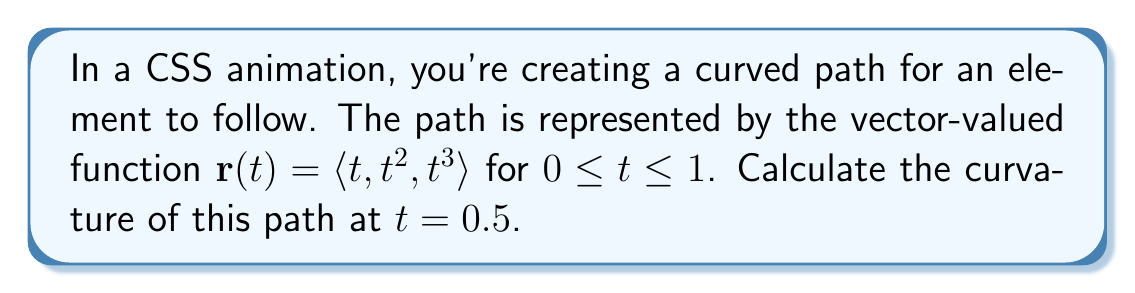Could you help me with this problem? To calculate the curvature of a vector-valued function, we use the formula:

$$\kappa = \frac{|\mathbf{r}'(t) \times \mathbf{r}''(t)|}{|\mathbf{r}'(t)|^3}$$

Let's break this down step-by-step:

1) First, we need to find $\mathbf{r}'(t)$ and $\mathbf{r}''(t)$:

   $\mathbf{r}'(t) = \langle 1, 2t, 3t^2 \rangle$
   $\mathbf{r}''(t) = \langle 0, 2, 6t \rangle$

2) Now, let's evaluate these at $t = 0.5$:

   $\mathbf{r}'(0.5) = \langle 1, 1, 0.75 \rangle$
   $\mathbf{r}''(0.5) = \langle 0, 2, 3 \rangle$

3) Next, we need to calculate the cross product $\mathbf{r}'(0.5) \times \mathbf{r}''(0.5)$:

   $\mathbf{r}'(0.5) \times \mathbf{r}''(0.5) = \langle 1(3) - 0.75(2), 0.75(0) - 1(3), 1(2) - 1(0) \rangle = \langle 1.5, -3, 2 \rangle$

4) Now we can calculate the magnitudes:

   $|\mathbf{r}'(0.5) \times \mathbf{r}''(0.5)| = \sqrt{1.5^2 + (-3)^2 + 2^2} = \sqrt{2.25 + 9 + 4} = \sqrt{15.25}$

   $|\mathbf{r}'(0.5)| = \sqrt{1^2 + 1^2 + 0.75^2} = \sqrt{2.5625}$

5) Finally, we can plug these values into our curvature formula:

   $$\kappa = \frac{\sqrt{15.25}}{(\sqrt{2.5625})^3} = \frac{\sqrt{15.25}}{(2.5625)^{3/2}} \approx 0.9553$$
Answer: The curvature of the path at $t = 0.5$ is approximately 0.9553. 